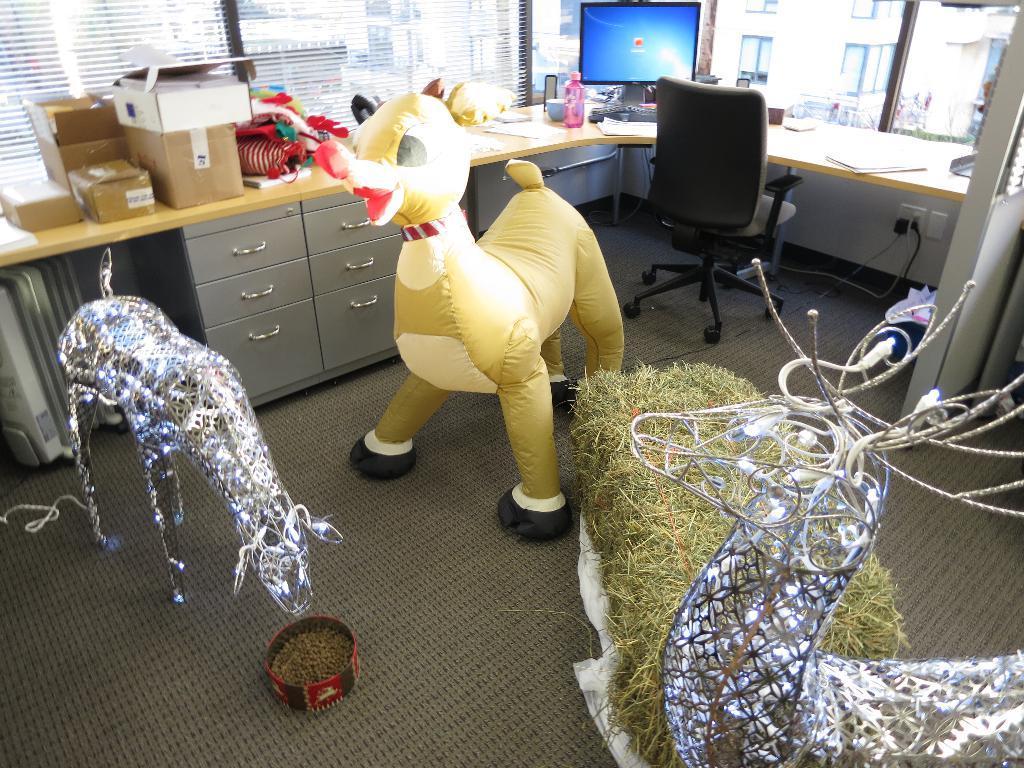Can you describe this image briefly? These looks like the toys on the floor. is a table with a monitor,keyboard,water bottle,papers,and cardboard boxes placed on it. These are the drawers. This is an empty chair. This is a socket with cables attached. These are the windows. 